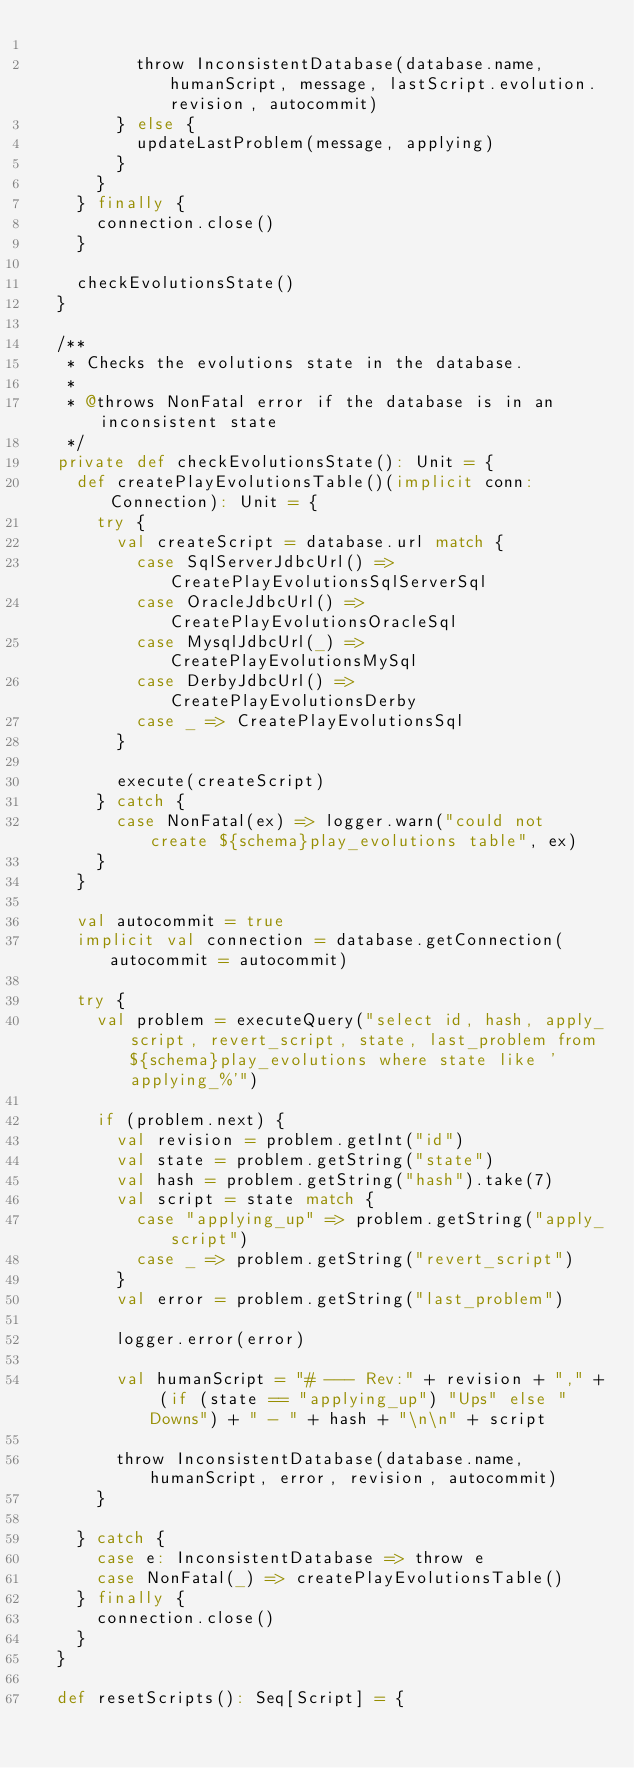Convert code to text. <code><loc_0><loc_0><loc_500><loc_500><_Scala_>
          throw InconsistentDatabase(database.name, humanScript, message, lastScript.evolution.revision, autocommit)
        } else {
          updateLastProblem(message, applying)
        }
      }
    } finally {
      connection.close()
    }

    checkEvolutionsState()
  }

  /**
   * Checks the evolutions state in the database.
   *
   * @throws NonFatal error if the database is in an inconsistent state
   */
  private def checkEvolutionsState(): Unit = {
    def createPlayEvolutionsTable()(implicit conn: Connection): Unit = {
      try {
        val createScript = database.url match {
          case SqlServerJdbcUrl() => CreatePlayEvolutionsSqlServerSql
          case OracleJdbcUrl() => CreatePlayEvolutionsOracleSql
          case MysqlJdbcUrl(_) => CreatePlayEvolutionsMySql
          case DerbyJdbcUrl() => CreatePlayEvolutionsDerby
          case _ => CreatePlayEvolutionsSql
        }

        execute(createScript)
      } catch {
        case NonFatal(ex) => logger.warn("could not create ${schema}play_evolutions table", ex)
      }
    }

    val autocommit = true
    implicit val connection = database.getConnection(autocommit = autocommit)

    try {
      val problem = executeQuery("select id, hash, apply_script, revert_script, state, last_problem from ${schema}play_evolutions where state like 'applying_%'")

      if (problem.next) {
        val revision = problem.getInt("id")
        val state = problem.getString("state")
        val hash = problem.getString("hash").take(7)
        val script = state match {
          case "applying_up" => problem.getString("apply_script")
          case _ => problem.getString("revert_script")
        }
        val error = problem.getString("last_problem")

        logger.error(error)

        val humanScript = "# --- Rev:" + revision + "," + (if (state == "applying_up") "Ups" else "Downs") + " - " + hash + "\n\n" + script

        throw InconsistentDatabase(database.name, humanScript, error, revision, autocommit)
      }

    } catch {
      case e: InconsistentDatabase => throw e
      case NonFatal(_) => createPlayEvolutionsTable()
    } finally {
      connection.close()
    }
  }

  def resetScripts(): Seq[Script] = {</code> 